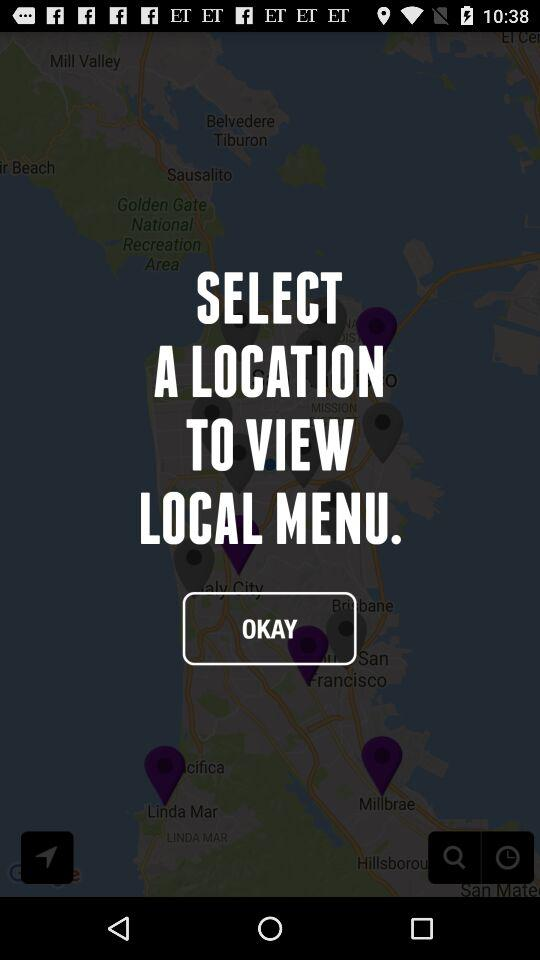What is your current location?
When the provided information is insufficient, respond with <no answer>. <no answer> 